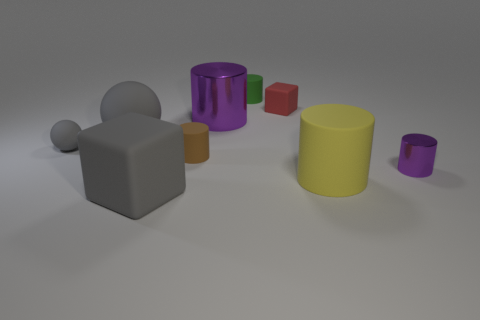Is there any object in the image that stands out to you the most? The large yellow cylinder stands out due to its bright color and size, which contrasts significantly with the smaller and more muted-colored objects in the image. 